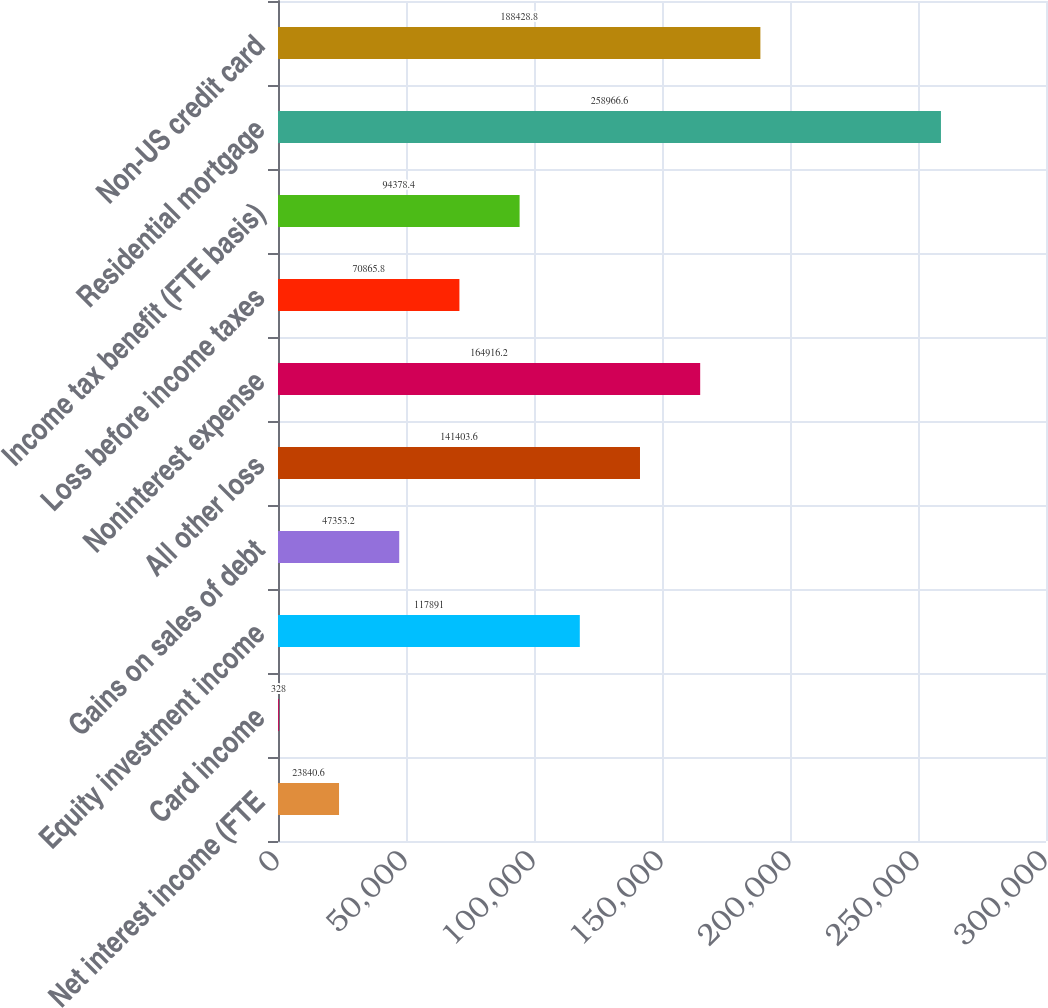Convert chart. <chart><loc_0><loc_0><loc_500><loc_500><bar_chart><fcel>Net interest income (FTE<fcel>Card income<fcel>Equity investment income<fcel>Gains on sales of debt<fcel>All other loss<fcel>Noninterest expense<fcel>Loss before income taxes<fcel>Income tax benefit (FTE basis)<fcel>Residential mortgage<fcel>Non-US credit card<nl><fcel>23840.6<fcel>328<fcel>117891<fcel>47353.2<fcel>141404<fcel>164916<fcel>70865.8<fcel>94378.4<fcel>258967<fcel>188429<nl></chart> 